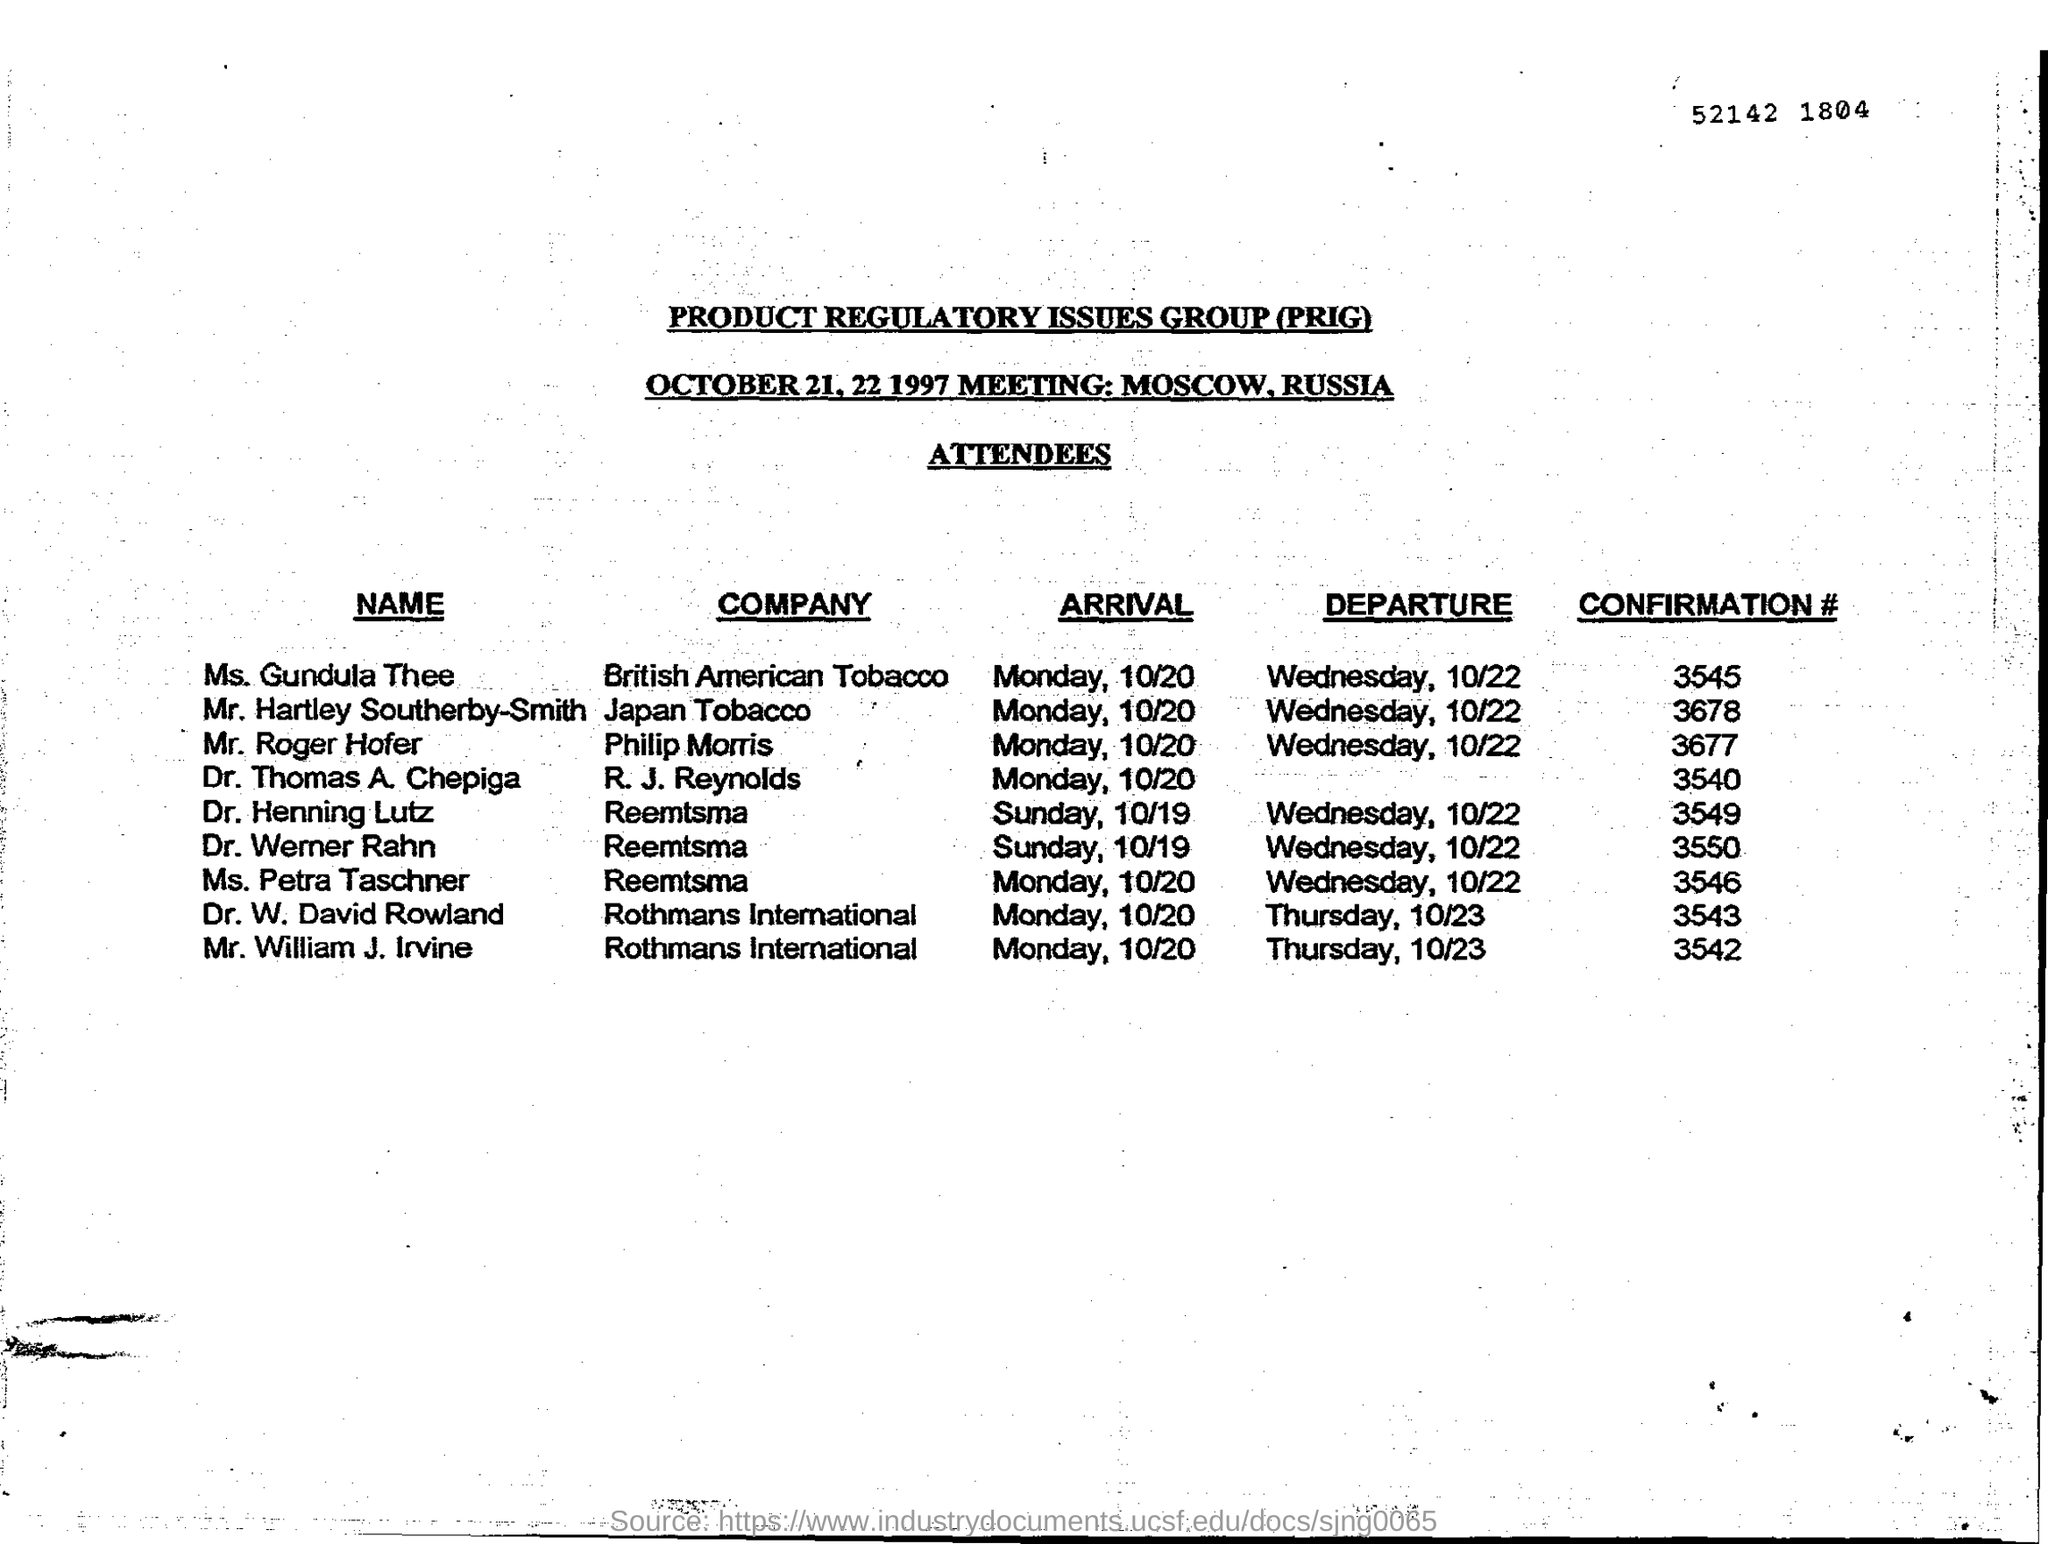What is the fullform of PRIG?
Make the answer very short. Product Regulatory Issues Group. What is the confirmation number of Dr. Werner Rahn?
Provide a succinct answer. 3550. For which company does Mr. Hartley Southerby-Smith work?
Keep it short and to the point. Japan Tobacco. Where is the meeting conducted?
Keep it short and to the point. Moscow. Which company's attendees will depart on Thursday?
Make the answer very short. Rothmans International. 